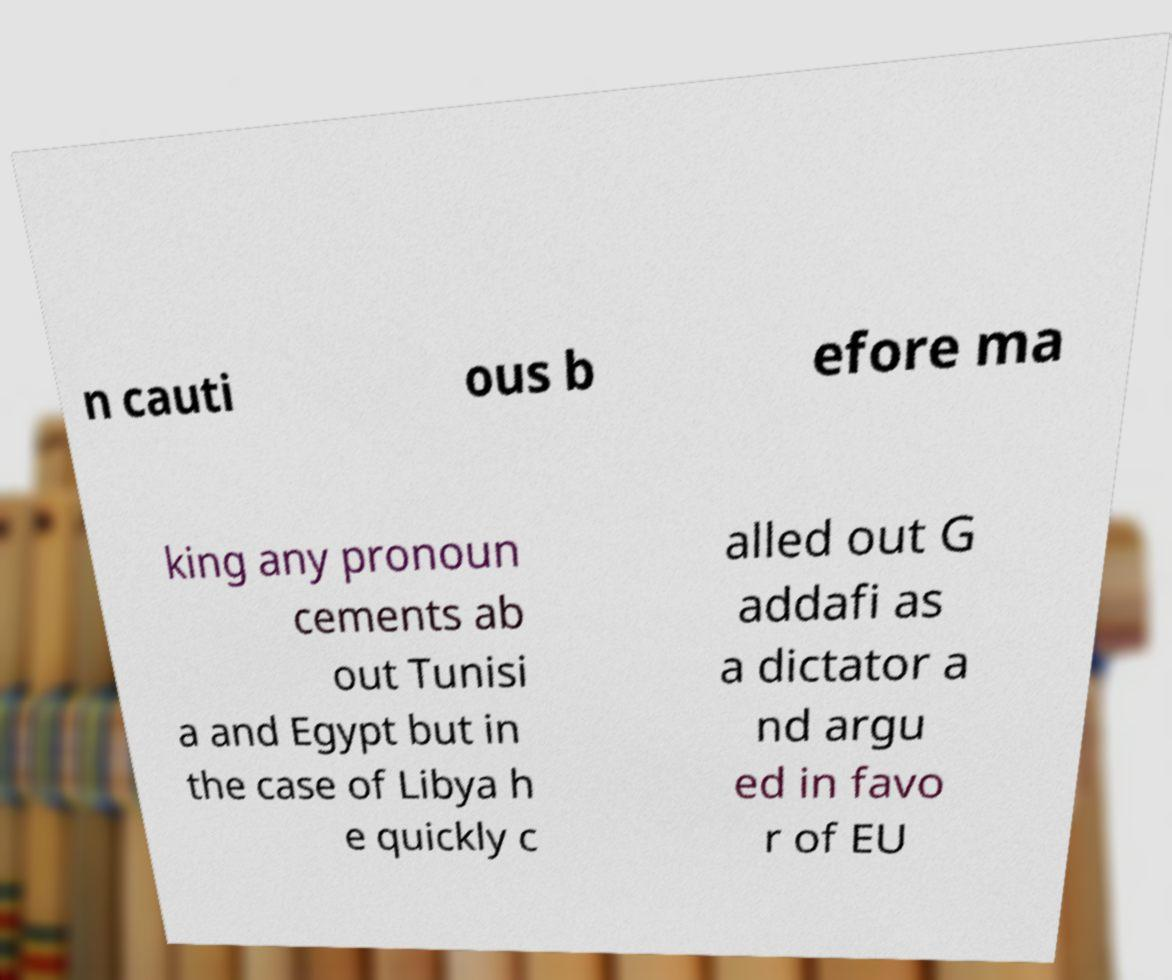Could you assist in decoding the text presented in this image and type it out clearly? n cauti ous b efore ma king any pronoun cements ab out Tunisi a and Egypt but in the case of Libya h e quickly c alled out G addafi as a dictator a nd argu ed in favo r of EU 